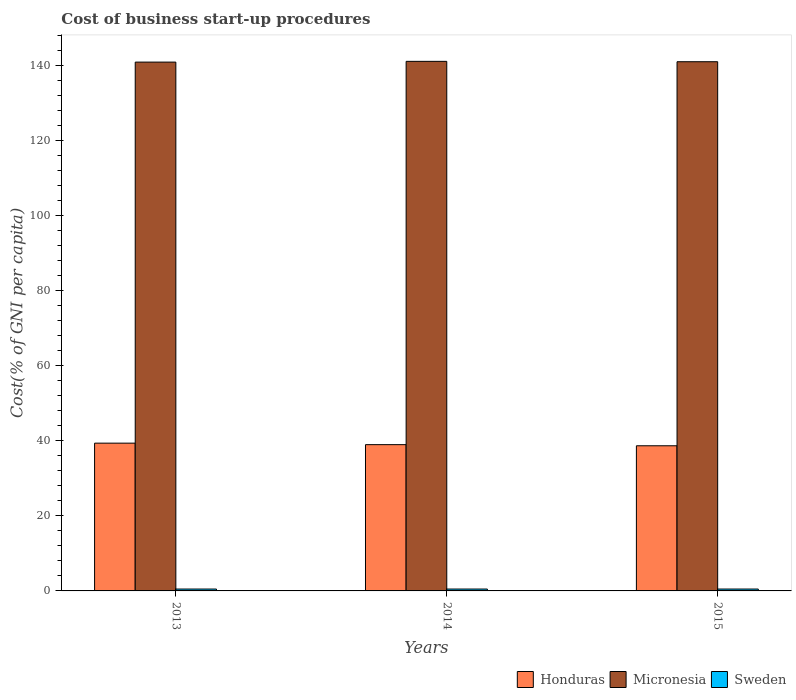Are the number of bars on each tick of the X-axis equal?
Your response must be concise. Yes. How many bars are there on the 2nd tick from the right?
Ensure brevity in your answer.  3. What is the label of the 2nd group of bars from the left?
Offer a terse response. 2014. In how many cases, is the number of bars for a given year not equal to the number of legend labels?
Offer a terse response. 0. What is the cost of business start-up procedures in Honduras in 2015?
Ensure brevity in your answer.  38.7. Across all years, what is the minimum cost of business start-up procedures in Micronesia?
Your answer should be very brief. 141. In which year was the cost of business start-up procedures in Honduras maximum?
Your response must be concise. 2013. In which year was the cost of business start-up procedures in Micronesia minimum?
Ensure brevity in your answer.  2013. What is the total cost of business start-up procedures in Micronesia in the graph?
Offer a very short reply. 423.3. What is the difference between the cost of business start-up procedures in Micronesia in 2014 and the cost of business start-up procedures in Sweden in 2013?
Provide a succinct answer. 140.7. What is the average cost of business start-up procedures in Micronesia per year?
Offer a terse response. 141.1. In the year 2015, what is the difference between the cost of business start-up procedures in Micronesia and cost of business start-up procedures in Sweden?
Give a very brief answer. 140.6. What is the ratio of the cost of business start-up procedures in Honduras in 2013 to that in 2014?
Keep it short and to the point. 1.01. What is the difference between the highest and the second highest cost of business start-up procedures in Micronesia?
Ensure brevity in your answer.  0.1. What is the difference between the highest and the lowest cost of business start-up procedures in Sweden?
Your answer should be very brief. 0. What does the 1st bar from the left in 2015 represents?
Your answer should be very brief. Honduras. Is it the case that in every year, the sum of the cost of business start-up procedures in Honduras and cost of business start-up procedures in Micronesia is greater than the cost of business start-up procedures in Sweden?
Offer a terse response. Yes. Are all the bars in the graph horizontal?
Your answer should be very brief. No. How many years are there in the graph?
Offer a terse response. 3. What is the difference between two consecutive major ticks on the Y-axis?
Ensure brevity in your answer.  20. How many legend labels are there?
Give a very brief answer. 3. What is the title of the graph?
Provide a succinct answer. Cost of business start-up procedures. What is the label or title of the Y-axis?
Provide a succinct answer. Cost(% of GNI per capita). What is the Cost(% of GNI per capita) in Honduras in 2013?
Provide a succinct answer. 39.4. What is the Cost(% of GNI per capita) of Micronesia in 2013?
Keep it short and to the point. 141. What is the Cost(% of GNI per capita) in Sweden in 2013?
Give a very brief answer. 0.5. What is the Cost(% of GNI per capita) in Honduras in 2014?
Your answer should be compact. 39. What is the Cost(% of GNI per capita) of Micronesia in 2014?
Give a very brief answer. 141.2. What is the Cost(% of GNI per capita) of Honduras in 2015?
Your answer should be compact. 38.7. What is the Cost(% of GNI per capita) of Micronesia in 2015?
Your response must be concise. 141.1. Across all years, what is the maximum Cost(% of GNI per capita) of Honduras?
Provide a succinct answer. 39.4. Across all years, what is the maximum Cost(% of GNI per capita) in Micronesia?
Offer a terse response. 141.2. Across all years, what is the maximum Cost(% of GNI per capita) in Sweden?
Give a very brief answer. 0.5. Across all years, what is the minimum Cost(% of GNI per capita) of Honduras?
Your answer should be compact. 38.7. Across all years, what is the minimum Cost(% of GNI per capita) in Micronesia?
Offer a terse response. 141. Across all years, what is the minimum Cost(% of GNI per capita) of Sweden?
Give a very brief answer. 0.5. What is the total Cost(% of GNI per capita) in Honduras in the graph?
Offer a very short reply. 117.1. What is the total Cost(% of GNI per capita) of Micronesia in the graph?
Your response must be concise. 423.3. What is the total Cost(% of GNI per capita) of Sweden in the graph?
Offer a very short reply. 1.5. What is the difference between the Cost(% of GNI per capita) of Honduras in 2013 and that in 2015?
Offer a terse response. 0.7. What is the difference between the Cost(% of GNI per capita) in Micronesia in 2013 and that in 2015?
Your answer should be compact. -0.1. What is the difference between the Cost(% of GNI per capita) of Sweden in 2013 and that in 2015?
Your answer should be very brief. 0. What is the difference between the Cost(% of GNI per capita) in Honduras in 2014 and that in 2015?
Ensure brevity in your answer.  0.3. What is the difference between the Cost(% of GNI per capita) of Micronesia in 2014 and that in 2015?
Your answer should be very brief. 0.1. What is the difference between the Cost(% of GNI per capita) of Sweden in 2014 and that in 2015?
Offer a very short reply. 0. What is the difference between the Cost(% of GNI per capita) in Honduras in 2013 and the Cost(% of GNI per capita) in Micronesia in 2014?
Provide a short and direct response. -101.8. What is the difference between the Cost(% of GNI per capita) of Honduras in 2013 and the Cost(% of GNI per capita) of Sweden in 2014?
Your answer should be compact. 38.9. What is the difference between the Cost(% of GNI per capita) in Micronesia in 2013 and the Cost(% of GNI per capita) in Sweden in 2014?
Give a very brief answer. 140.5. What is the difference between the Cost(% of GNI per capita) in Honduras in 2013 and the Cost(% of GNI per capita) in Micronesia in 2015?
Ensure brevity in your answer.  -101.7. What is the difference between the Cost(% of GNI per capita) in Honduras in 2013 and the Cost(% of GNI per capita) in Sweden in 2015?
Your response must be concise. 38.9. What is the difference between the Cost(% of GNI per capita) in Micronesia in 2013 and the Cost(% of GNI per capita) in Sweden in 2015?
Provide a short and direct response. 140.5. What is the difference between the Cost(% of GNI per capita) of Honduras in 2014 and the Cost(% of GNI per capita) of Micronesia in 2015?
Offer a terse response. -102.1. What is the difference between the Cost(% of GNI per capita) of Honduras in 2014 and the Cost(% of GNI per capita) of Sweden in 2015?
Offer a very short reply. 38.5. What is the difference between the Cost(% of GNI per capita) of Micronesia in 2014 and the Cost(% of GNI per capita) of Sweden in 2015?
Give a very brief answer. 140.7. What is the average Cost(% of GNI per capita) in Honduras per year?
Give a very brief answer. 39.03. What is the average Cost(% of GNI per capita) in Micronesia per year?
Your answer should be compact. 141.1. What is the average Cost(% of GNI per capita) in Sweden per year?
Ensure brevity in your answer.  0.5. In the year 2013, what is the difference between the Cost(% of GNI per capita) in Honduras and Cost(% of GNI per capita) in Micronesia?
Offer a very short reply. -101.6. In the year 2013, what is the difference between the Cost(% of GNI per capita) of Honduras and Cost(% of GNI per capita) of Sweden?
Your answer should be very brief. 38.9. In the year 2013, what is the difference between the Cost(% of GNI per capita) of Micronesia and Cost(% of GNI per capita) of Sweden?
Your answer should be very brief. 140.5. In the year 2014, what is the difference between the Cost(% of GNI per capita) in Honduras and Cost(% of GNI per capita) in Micronesia?
Offer a terse response. -102.2. In the year 2014, what is the difference between the Cost(% of GNI per capita) of Honduras and Cost(% of GNI per capita) of Sweden?
Ensure brevity in your answer.  38.5. In the year 2014, what is the difference between the Cost(% of GNI per capita) of Micronesia and Cost(% of GNI per capita) of Sweden?
Your response must be concise. 140.7. In the year 2015, what is the difference between the Cost(% of GNI per capita) in Honduras and Cost(% of GNI per capita) in Micronesia?
Your response must be concise. -102.4. In the year 2015, what is the difference between the Cost(% of GNI per capita) in Honduras and Cost(% of GNI per capita) in Sweden?
Ensure brevity in your answer.  38.2. In the year 2015, what is the difference between the Cost(% of GNI per capita) of Micronesia and Cost(% of GNI per capita) of Sweden?
Offer a terse response. 140.6. What is the ratio of the Cost(% of GNI per capita) of Honduras in 2013 to that in 2014?
Ensure brevity in your answer.  1.01. What is the ratio of the Cost(% of GNI per capita) in Micronesia in 2013 to that in 2014?
Offer a very short reply. 1. What is the ratio of the Cost(% of GNI per capita) of Sweden in 2013 to that in 2014?
Provide a succinct answer. 1. What is the ratio of the Cost(% of GNI per capita) of Honduras in 2013 to that in 2015?
Your answer should be very brief. 1.02. What is the ratio of the Cost(% of GNI per capita) of Sweden in 2013 to that in 2015?
Offer a very short reply. 1. What is the ratio of the Cost(% of GNI per capita) of Micronesia in 2014 to that in 2015?
Keep it short and to the point. 1. What is the difference between the highest and the lowest Cost(% of GNI per capita) in Micronesia?
Make the answer very short. 0.2. What is the difference between the highest and the lowest Cost(% of GNI per capita) in Sweden?
Ensure brevity in your answer.  0. 